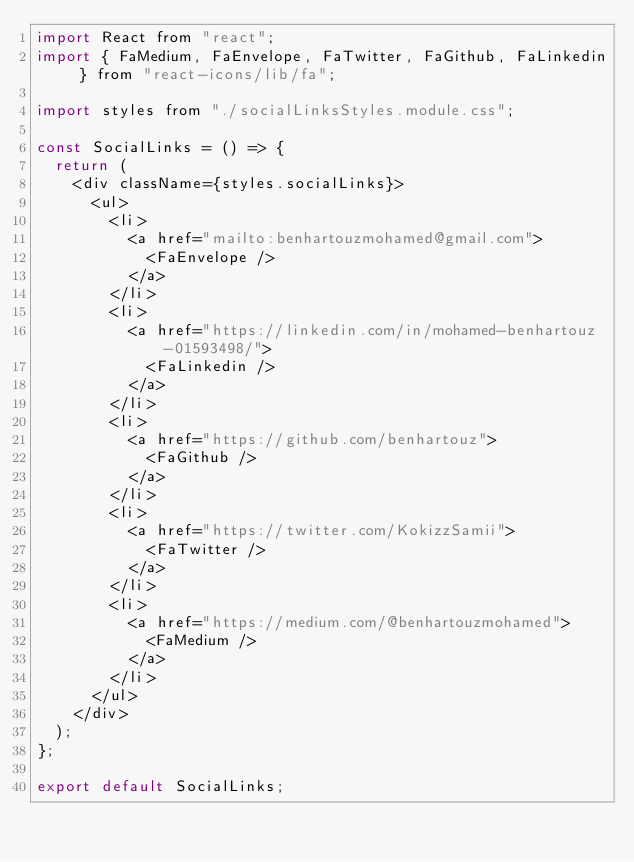Convert code to text. <code><loc_0><loc_0><loc_500><loc_500><_JavaScript_>import React from "react";
import { FaMedium, FaEnvelope, FaTwitter, FaGithub, FaLinkedin } from "react-icons/lib/fa";

import styles from "./socialLinksStyles.module.css";

const SocialLinks = () => {
  return (
    <div className={styles.socialLinks}>
      <ul>
        <li>
          <a href="mailto:benhartouzmohamed@gmail.com">
            <FaEnvelope />
          </a>
        </li>
        <li>
          <a href="https://linkedin.com/in/mohamed-benhartouz-01593498/">
            <FaLinkedin />
          </a>
        </li>
        <li>
          <a href="https://github.com/benhartouz">
            <FaGithub />
          </a>
        </li>
        <li>
          <a href="https://twitter.com/KokizzSamii">
            <FaTwitter />
          </a>
        </li>
        <li>
          <a href="https://medium.com/@benhartouzmohamed">
            <FaMedium />
          </a>
        </li>
      </ul>
    </div>
  );
};

export default SocialLinks;
</code> 